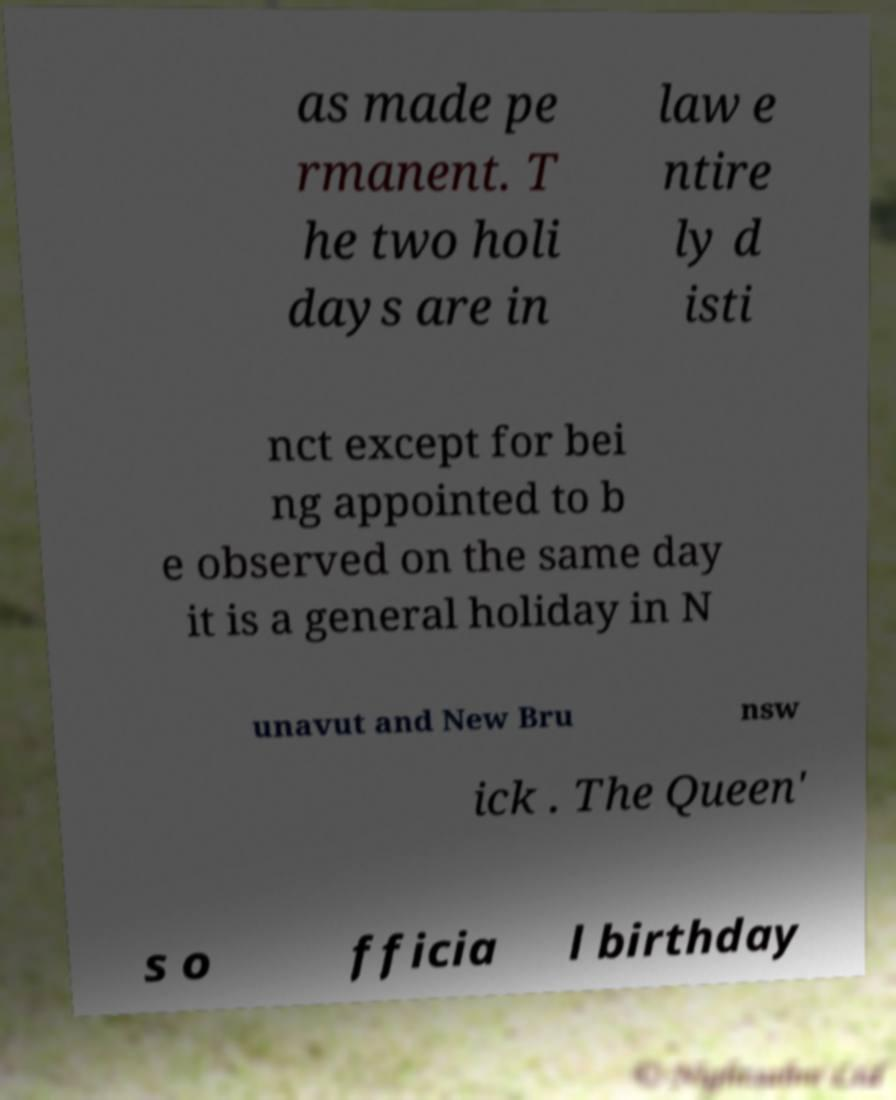Could you extract and type out the text from this image? as made pe rmanent. T he two holi days are in law e ntire ly d isti nct except for bei ng appointed to b e observed on the same day it is a general holiday in N unavut and New Bru nsw ick . The Queen' s o fficia l birthday 